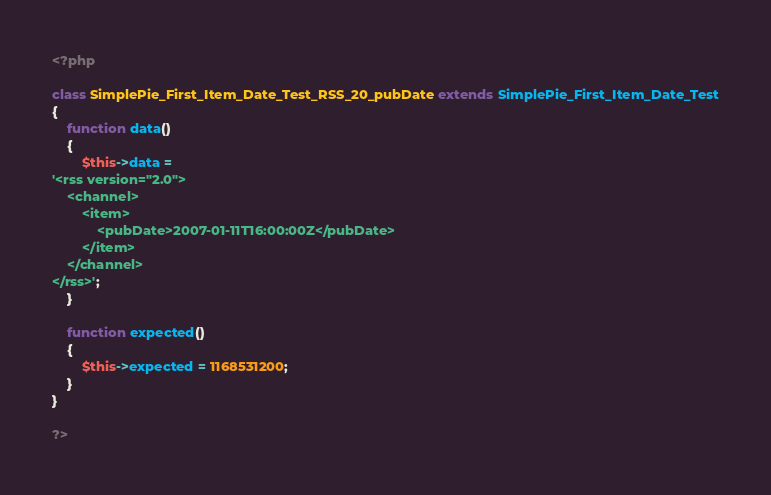<code> <loc_0><loc_0><loc_500><loc_500><_PHP_><?php

class SimplePie_First_Item_Date_Test_RSS_20_pubDate extends SimplePie_First_Item_Date_Test
{
	function data()
	{
		$this->data = 
'<rss version="2.0">
	<channel>
		<item>
			<pubDate>2007-01-11T16:00:00Z</pubDate>
		</item>
	</channel>
</rss>';
	}
	
	function expected()
	{
		$this->expected = 1168531200;
	}
}

?></code> 